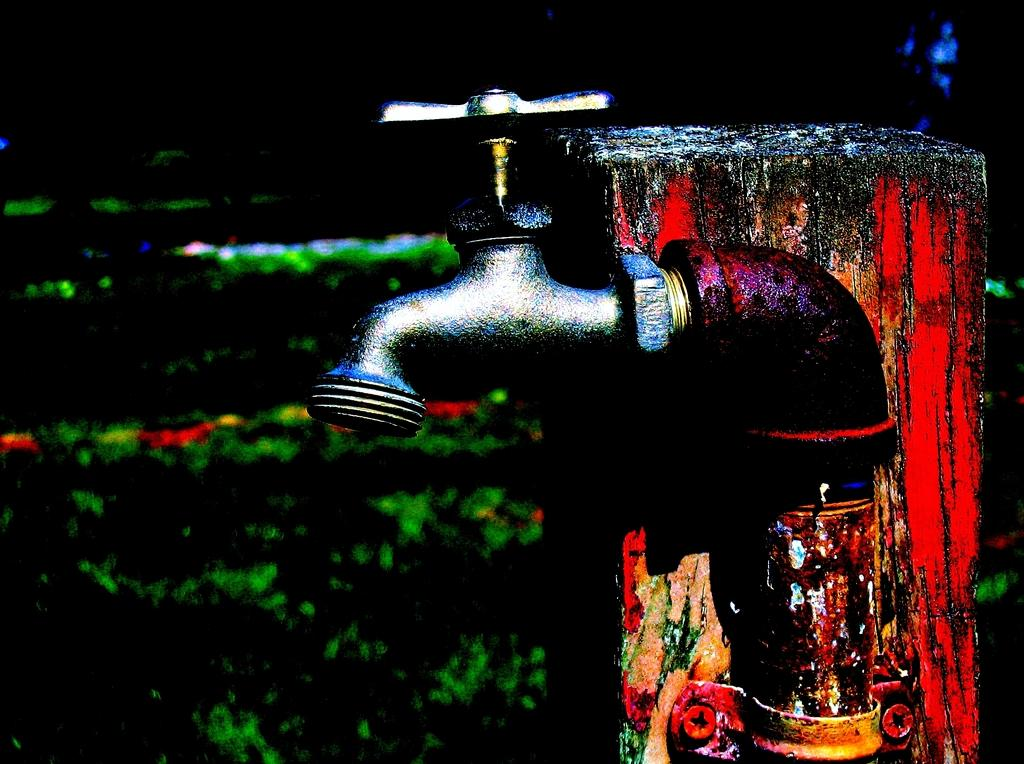What is the main object in the image? There is a tap to a pipe in the image. Where is the tap located? The tap is on a platform. Can you describe the background of the image? The background of the image is dark and not clear to describe. What type of engine can be seen powering the tap in the image? There is no engine present in the image; it only features a tap to a pipe on a platform. 